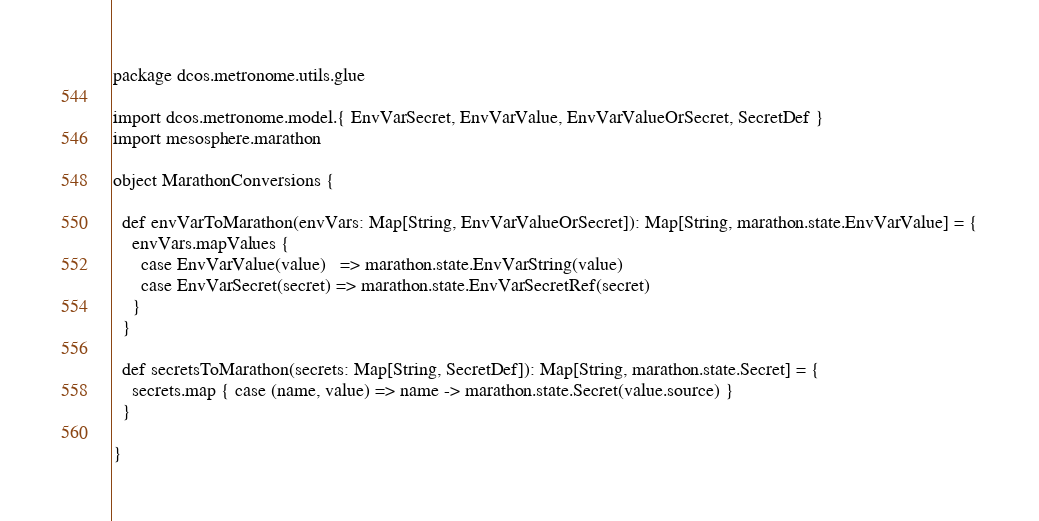Convert code to text. <code><loc_0><loc_0><loc_500><loc_500><_Scala_>package dcos.metronome.utils.glue

import dcos.metronome.model.{ EnvVarSecret, EnvVarValue, EnvVarValueOrSecret, SecretDef }
import mesosphere.marathon

object MarathonConversions {

  def envVarToMarathon(envVars: Map[String, EnvVarValueOrSecret]): Map[String, marathon.state.EnvVarValue] = {
    envVars.mapValues {
      case EnvVarValue(value)   => marathon.state.EnvVarString(value)
      case EnvVarSecret(secret) => marathon.state.EnvVarSecretRef(secret)
    }
  }

  def secretsToMarathon(secrets: Map[String, SecretDef]): Map[String, marathon.state.Secret] = {
    secrets.map { case (name, value) => name -> marathon.state.Secret(value.source) }
  }

}
</code> 